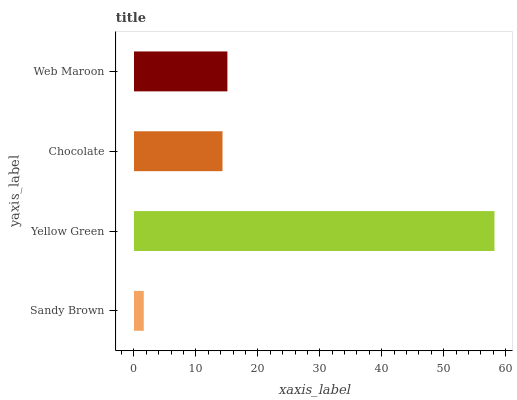Is Sandy Brown the minimum?
Answer yes or no. Yes. Is Yellow Green the maximum?
Answer yes or no. Yes. Is Chocolate the minimum?
Answer yes or no. No. Is Chocolate the maximum?
Answer yes or no. No. Is Yellow Green greater than Chocolate?
Answer yes or no. Yes. Is Chocolate less than Yellow Green?
Answer yes or no. Yes. Is Chocolate greater than Yellow Green?
Answer yes or no. No. Is Yellow Green less than Chocolate?
Answer yes or no. No. Is Web Maroon the high median?
Answer yes or no. Yes. Is Chocolate the low median?
Answer yes or no. Yes. Is Chocolate the high median?
Answer yes or no. No. Is Sandy Brown the low median?
Answer yes or no. No. 